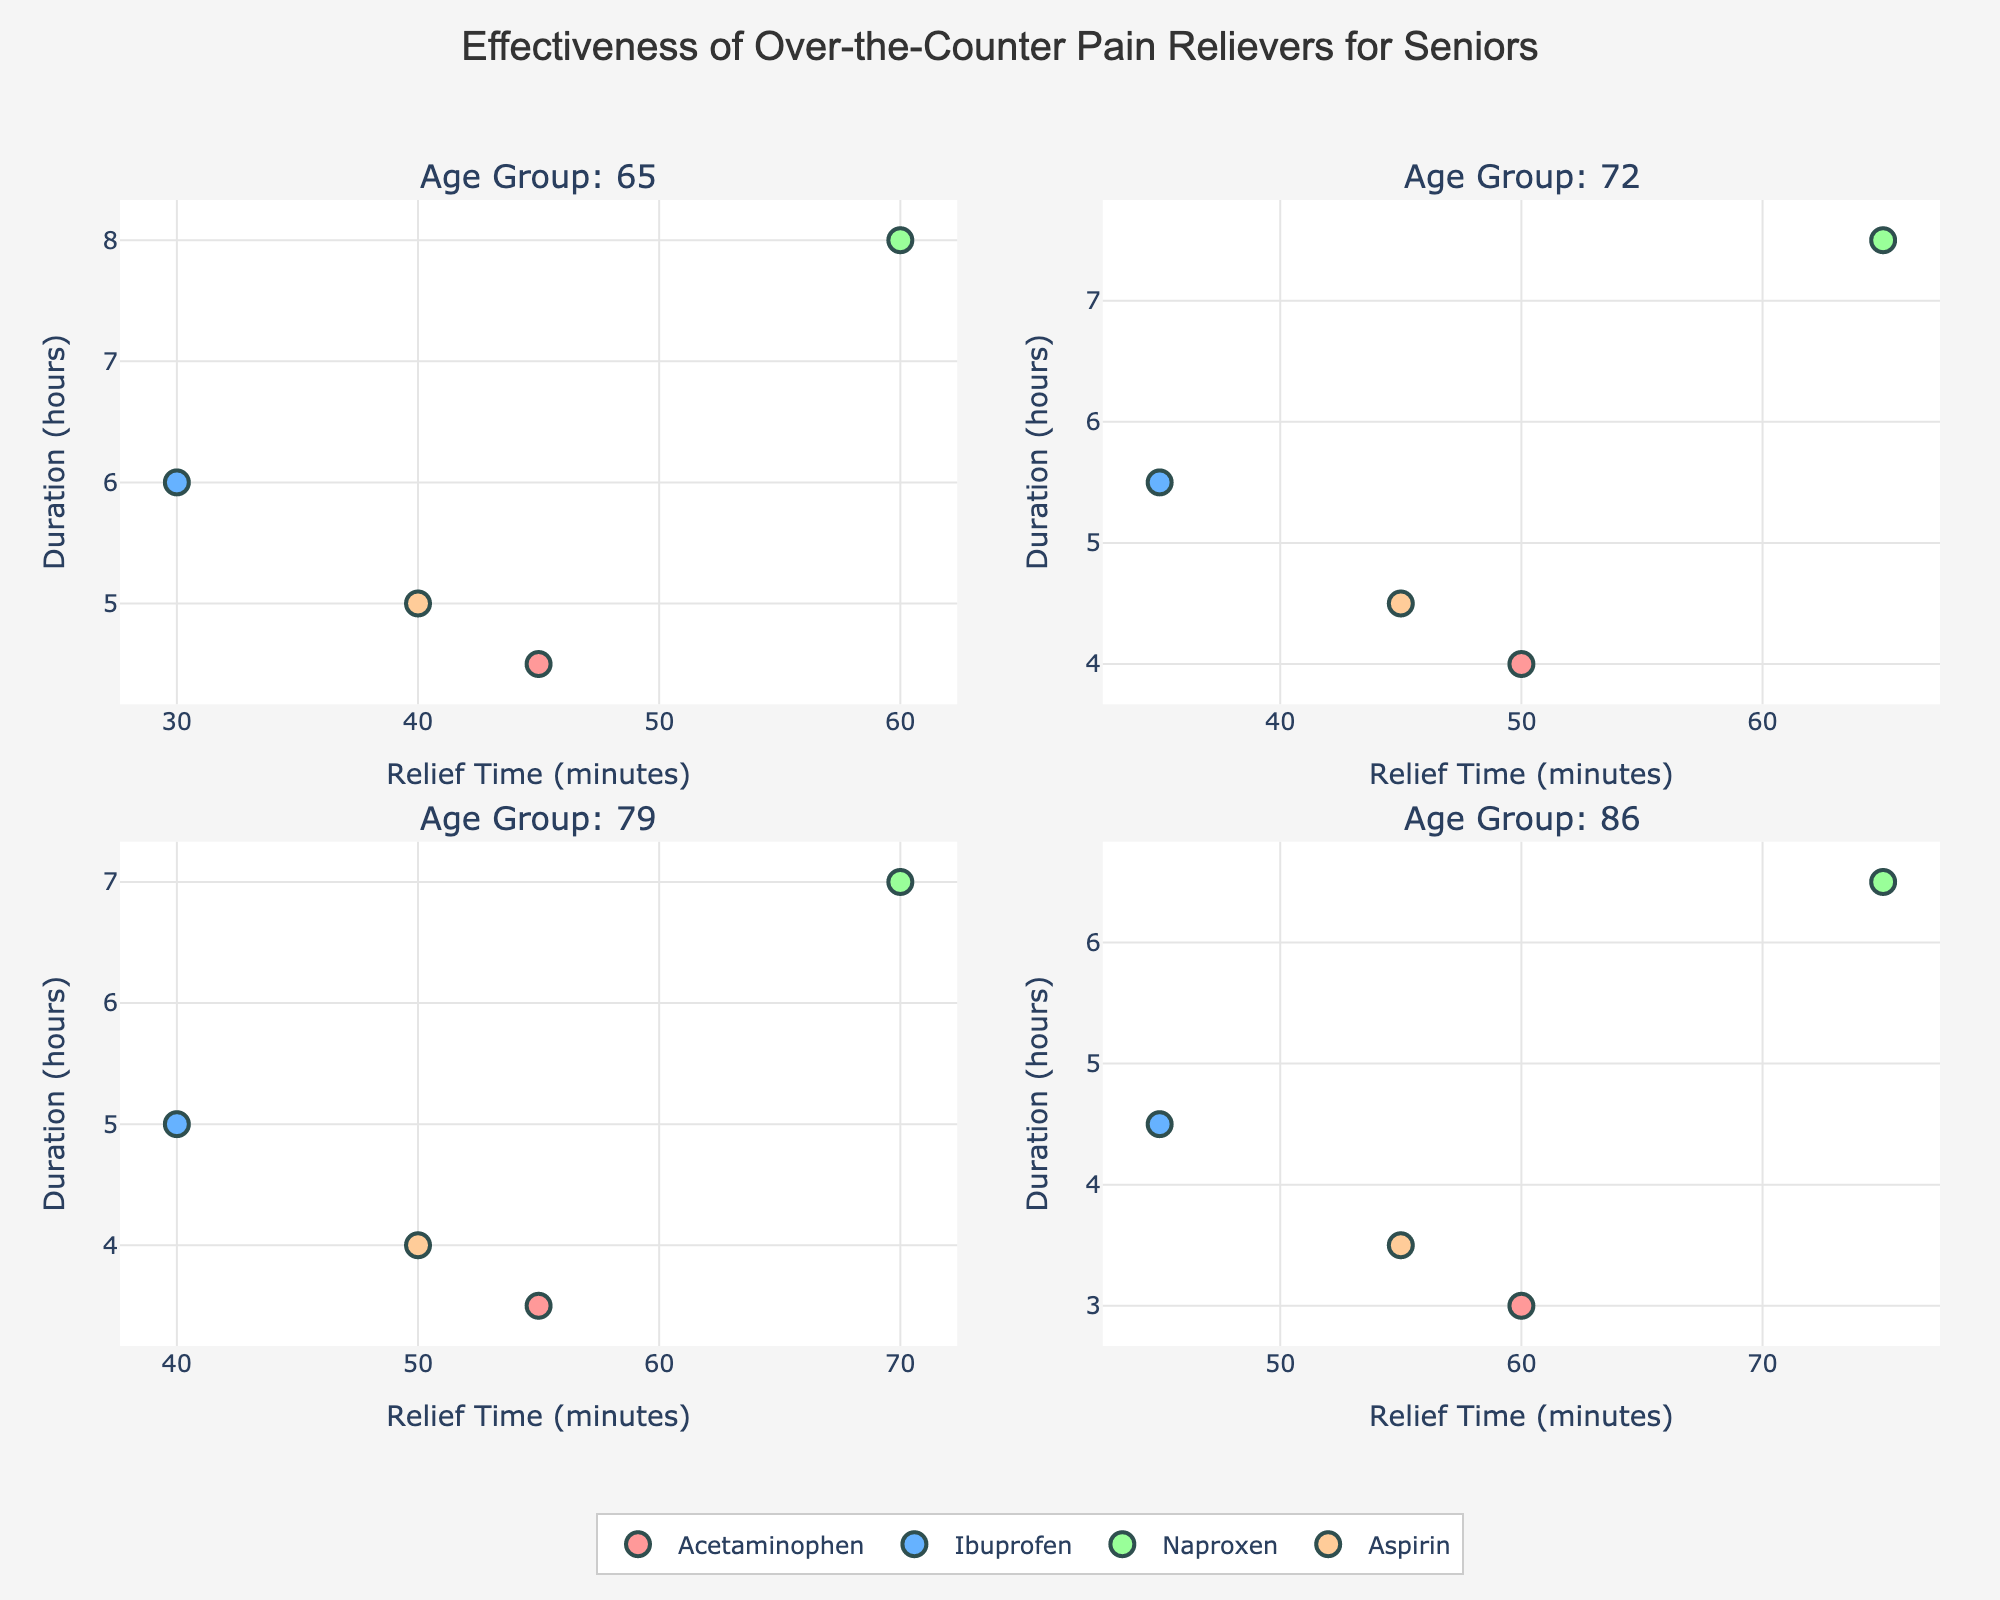What's the title of the figure? The title is located at the top of the figure, often in a larger and bolder font than other text elements.
Answer: Effectiveness of Over-the-Counter Pain Relievers for Seniors How many age groups are represented in the figure? There are four subplot titles, each mentioning a specific age group.
Answer: 4 Which medication has the shortest relief time for the 65 age group? By looking at the subplot for the 65 age group and comparing the x-coordinates (Relief Time in minutes) of the points, you can identify the shortest time.
Answer: Ibuprofen Which medication has the longest duration for the 86 age group? By examining the subplot for the 86 age group and comparing the y-coordinates (Duration in hours) of the points, you can find the longest duration.
Answer: Naproxen What is the relationship between relief time and duration for Naproxen in the 72 age group? In the 72 age group subplot, locate the point for Naproxen and observe its coordinates. Relief Time is the x-value, and Duration is the y-value.
Answer: Relief Time: 65 minutes, Duration: 7.5 hours Which age group shows the lowest duration for Acetaminophen? Identify the points for Acetaminophen in each subplot and compare their y-values (Duration in hours) to find the lowest.
Answer: 86 Across all age groups, which medication consistently takes the longest relief time? For each age group subplot, find the medication with the highest x-value (Relief Time in minutes), then identify which medication appears the most often with the highest values.
Answer: Naproxen What is the average duration for Ibuprofen across all age groups? Sum up the y-values (Duration in hours) for Ibuprofen in all subplots and divide by the number of data points (4).
Answer: (6 + 5.5 + 5 + 4.5) / 4 = 5.25 hours Which age group shows the smallest difference in relief time between Acetaminophen and Aspirin? For each age group subplot, calculate the difference in x-values (Relief Time in minutes) between Acetaminophen and Aspirin, then find the smallest difference.
Answer: 65 Is there any age group where all medications have a duration of 6 hours or more? Check each subplot to see if all y-values (Duration in hours) for the medications are 6 or above.
Answer: No 